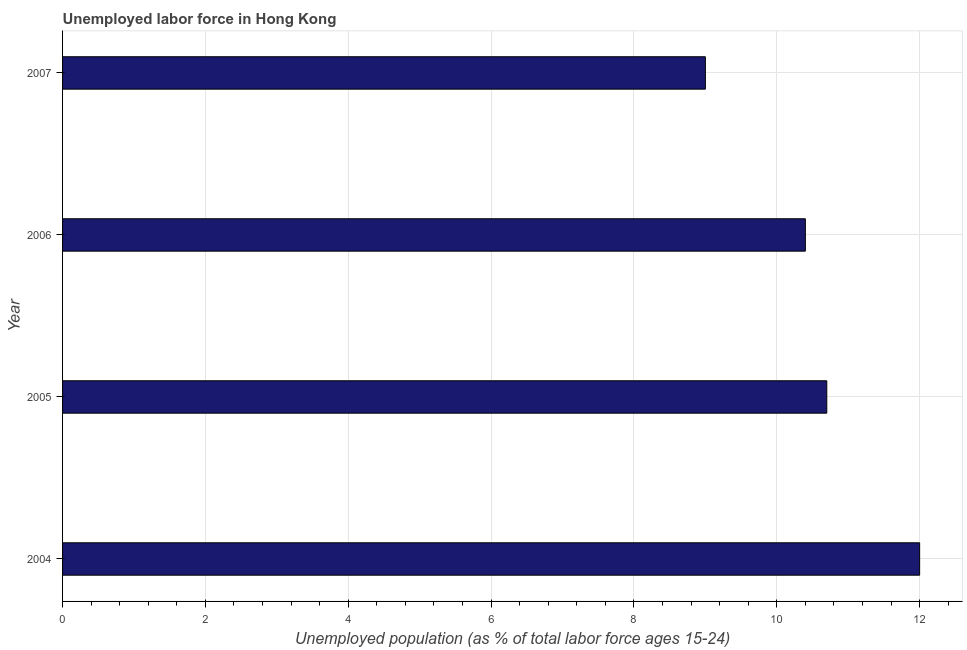Does the graph contain grids?
Your response must be concise. Yes. What is the title of the graph?
Give a very brief answer. Unemployed labor force in Hong Kong. What is the label or title of the X-axis?
Give a very brief answer. Unemployed population (as % of total labor force ages 15-24). What is the total unemployed youth population in 2006?
Your answer should be compact. 10.4. In which year was the total unemployed youth population maximum?
Your answer should be compact. 2004. In which year was the total unemployed youth population minimum?
Offer a very short reply. 2007. What is the sum of the total unemployed youth population?
Your answer should be compact. 42.1. What is the difference between the total unemployed youth population in 2004 and 2007?
Offer a terse response. 3. What is the average total unemployed youth population per year?
Your answer should be compact. 10.53. What is the median total unemployed youth population?
Ensure brevity in your answer.  10.55. In how many years, is the total unemployed youth population greater than 4.8 %?
Provide a short and direct response. 4. What is the ratio of the total unemployed youth population in 2005 to that in 2007?
Make the answer very short. 1.19. Is the total unemployed youth population in 2005 less than that in 2007?
Provide a short and direct response. No. Is the difference between the total unemployed youth population in 2006 and 2007 greater than the difference between any two years?
Your response must be concise. No. In how many years, is the total unemployed youth population greater than the average total unemployed youth population taken over all years?
Make the answer very short. 2. Are all the bars in the graph horizontal?
Ensure brevity in your answer.  Yes. What is the difference between two consecutive major ticks on the X-axis?
Offer a very short reply. 2. What is the Unemployed population (as % of total labor force ages 15-24) in 2004?
Keep it short and to the point. 12. What is the Unemployed population (as % of total labor force ages 15-24) of 2005?
Keep it short and to the point. 10.7. What is the Unemployed population (as % of total labor force ages 15-24) in 2006?
Your response must be concise. 10.4. What is the difference between the Unemployed population (as % of total labor force ages 15-24) in 2004 and 2006?
Your answer should be compact. 1.6. What is the difference between the Unemployed population (as % of total labor force ages 15-24) in 2005 and 2006?
Ensure brevity in your answer.  0.3. What is the ratio of the Unemployed population (as % of total labor force ages 15-24) in 2004 to that in 2005?
Give a very brief answer. 1.12. What is the ratio of the Unemployed population (as % of total labor force ages 15-24) in 2004 to that in 2006?
Your response must be concise. 1.15. What is the ratio of the Unemployed population (as % of total labor force ages 15-24) in 2004 to that in 2007?
Offer a terse response. 1.33. What is the ratio of the Unemployed population (as % of total labor force ages 15-24) in 2005 to that in 2007?
Make the answer very short. 1.19. What is the ratio of the Unemployed population (as % of total labor force ages 15-24) in 2006 to that in 2007?
Your answer should be compact. 1.16. 